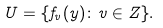Convert formula to latex. <formula><loc_0><loc_0><loc_500><loc_500>U = \{ f _ { v } ( y ) \colon v \in Z \} .</formula> 